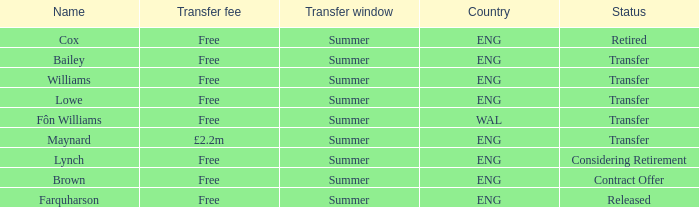What is Brown's transfer window? Summer. 